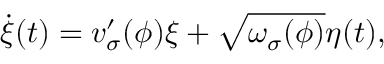Convert formula to latex. <formula><loc_0><loc_0><loc_500><loc_500>\dot { \xi } ( t ) = v _ { \sigma } ^ { \prime } ( \phi ) \xi + \sqrt { \omega _ { \sigma } ( \phi ) } \eta ( t ) ,</formula> 